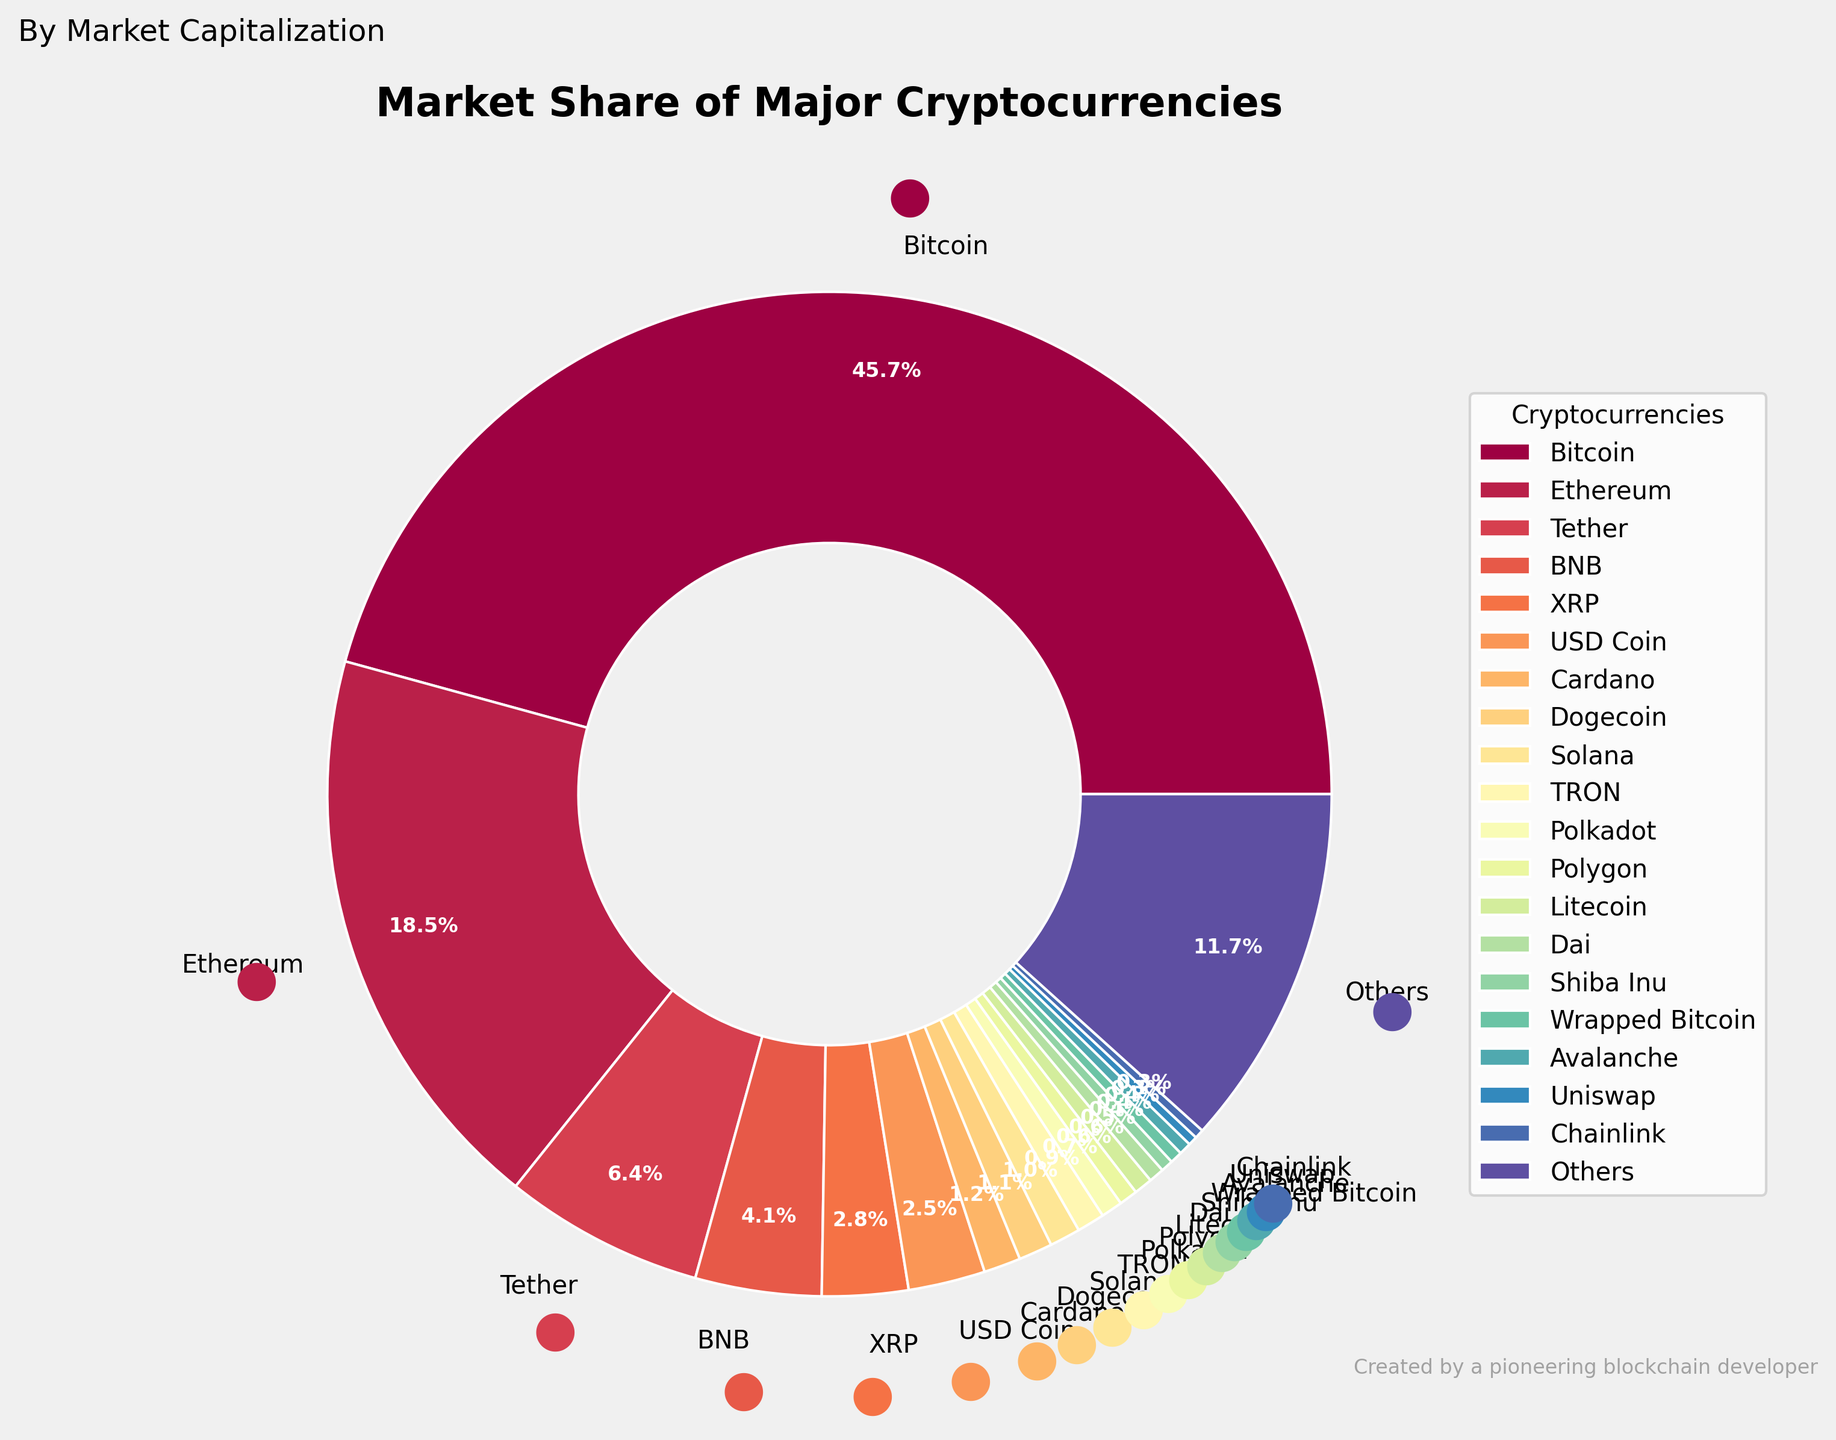What percentage of the market cap do Bitcoin and Ethereum together hold? To find this, you add the market cap percentages of Bitcoin and Ethereum. From the data, Bitcoin has 46.2% and Ethereum has 18.7%. So, 46.2 + 18.7 = 64.9%.
Answer: 64.9% Which cryptocurrency has a larger market share, Tether or BNB? To determine which cryptocurrency has a larger market share, compare the market cap percentages of Tether and BNB. Tether has 6.5% and BNB has 4.1%. Since 6.5 is greater than 4.1, Tether has a larger market share.
Answer: Tether Which three cryptocurrencies have the smallest market share? To identify the three cryptocurrencies with the smallest market share, look at the data and find the three lowest percentages. Those are Uniswap, Chainlink, and Dai, each having 0.3%, 0.3%, and 0.5% respectively.
Answer: Uniswap, Chainlink, Dai How much more market share does Bitcoin have compared to all cryptocurrencies categorized as "Others"? To find how much more market share Bitcoin has compared to "Others", subtract the market cap percentage of "Others" from Bitcoin's. Bitcoin has 46.2% and "Others" have 11.8%, so 46.2 - 11.8 = 34.4%.
Answer: 34.4% What is the combined market share of all cryptocurrencies with a market cap percentage less than 1%? First, identify all the cryptocurrencies with less than 1% market share: Cardano (1.2%), Dogecoin (1.1%), Solana (1.0%), TRON (0.9%), Polkadot (0.7%), Polygon (0.6%), Litecoin (0.6%), Dai (0.5%), Shiba Inu (0.4%), Wrapped Bitcoin (0.4%), Avalanche (0.4%), Uniswap (0.3%), Chainlink (0.3%), and add their percentages. 1.2 + 1.1 + 1.0 + 0.9 + 0.7 + 0.6 + 0.6 + 0.5 + 0.4 + 0.4 + 0.4 + 0.3 + 0.3 = 8.7%.
Answer: 8.7% What color is the wedge representing Cardano? To find the color of the wedge representing Cardano, look at the pie chart's legend for Cardano and identify the corresponding color in the chart.
Answer: [Here, you would refer to the specific color shown in the figure.] Which cryptocurrency has a similar market share percentage to USD Coin? To find a cryptocurrency with a similar market share to USD Coin, compare the percentages of other cryptocurrencies. USD Coin has 2.5%, and a similar percentage can be found with XRP, which has 2.8%.
Answer: XRP Is the market share of Dogecoin more than double that of Solana? Compare the market shares of Dogecoin and Solana. Dogecoin has 1.1% and Solana has 1.0%. Doubling Solana’s percentage gives 1.0 x 2 = 2.0%. Since 1.1% is not more than 2.0%, Dogecoin's market share is not more than double that of Solana.
Answer: No What is the total market share of stablecoins (Tether, USD Coin, Dai)? Add the market cap percentages of Tether (6.5%), USD Coin (2.5%), and Dai (0.5%). So, 6.5 + 2.5 + 0.5 = 9.5%.
Answer: 9.5% 